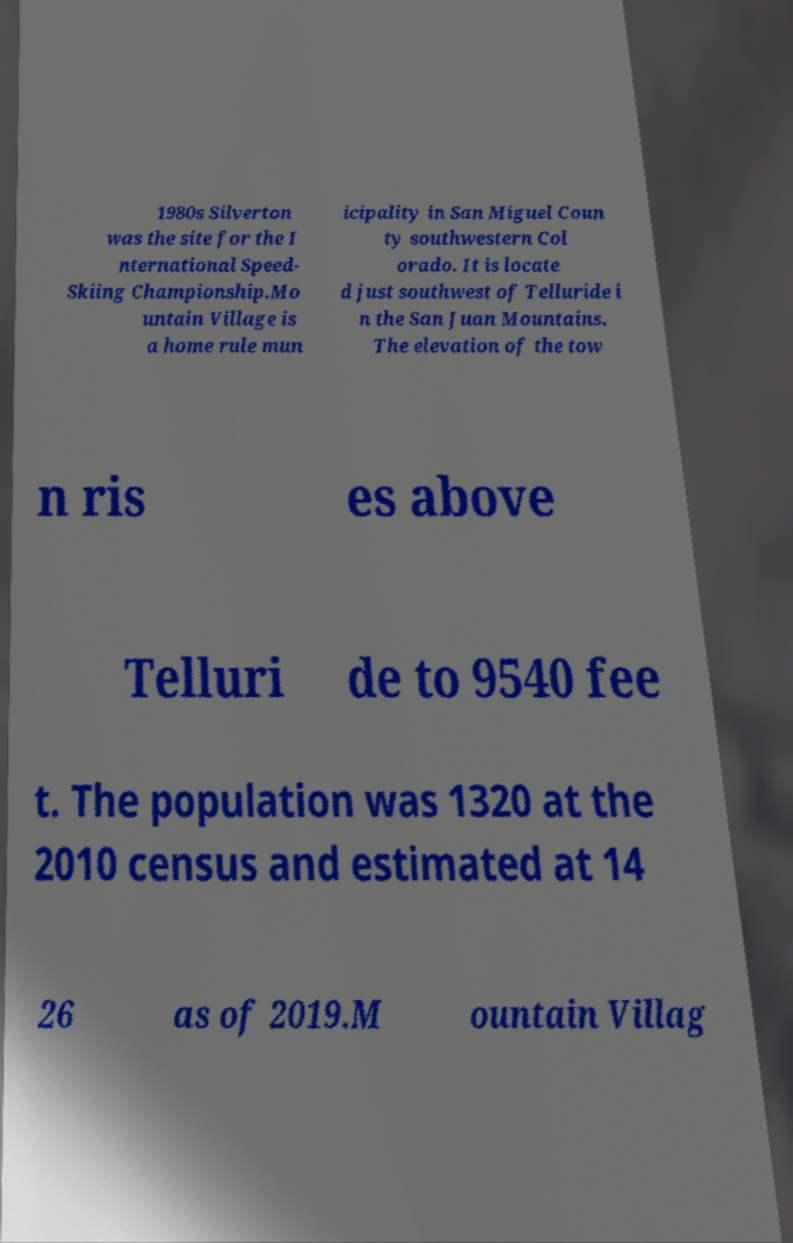For documentation purposes, I need the text within this image transcribed. Could you provide that? 1980s Silverton was the site for the I nternational Speed- Skiing Championship.Mo untain Village is a home rule mun icipality in San Miguel Coun ty southwestern Col orado. It is locate d just southwest of Telluride i n the San Juan Mountains. The elevation of the tow n ris es above Telluri de to 9540 fee t. The population was 1320 at the 2010 census and estimated at 14 26 as of 2019.M ountain Villag 